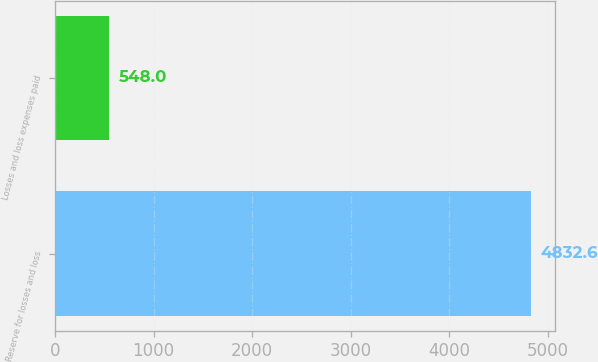Convert chart to OTSL. <chart><loc_0><loc_0><loc_500><loc_500><bar_chart><fcel>Reserve for losses and loss<fcel>Losses and loss expenses paid<nl><fcel>4832.6<fcel>548<nl></chart> 